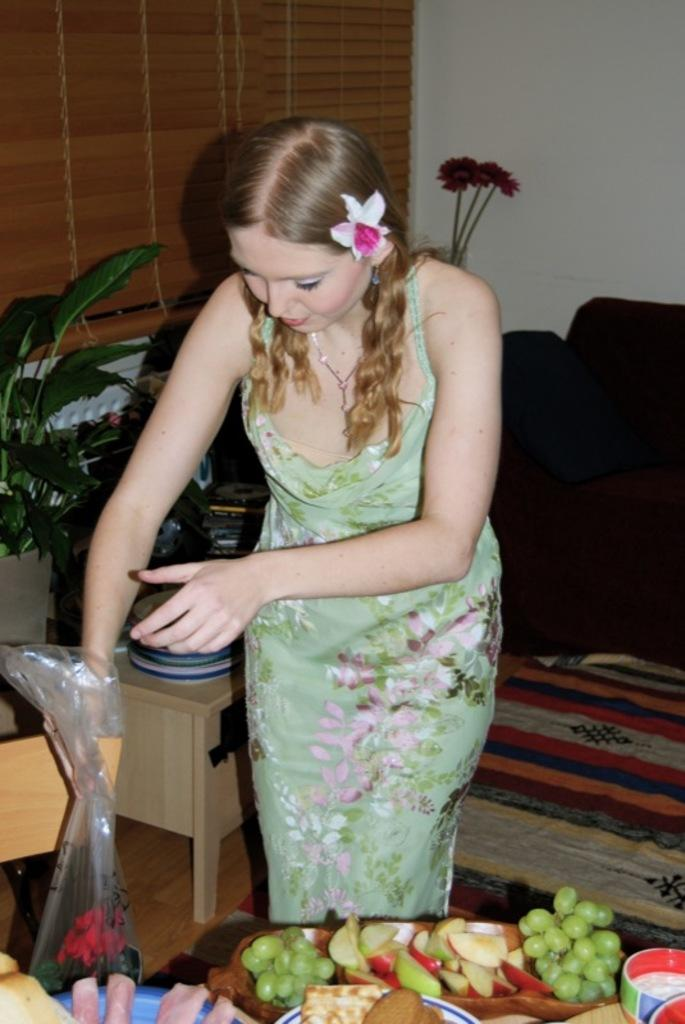What is the main subject of the image? There is a girl standing in the image. What can be seen on the plate in the image? There are fruits on a plate in the image. What type of plant is present in the image? There is a flower in the image. What is the background of the image made of? There is a wall in the image. What book is the girl reading in the image? There is no book present in the image; the girl is simply standing. 